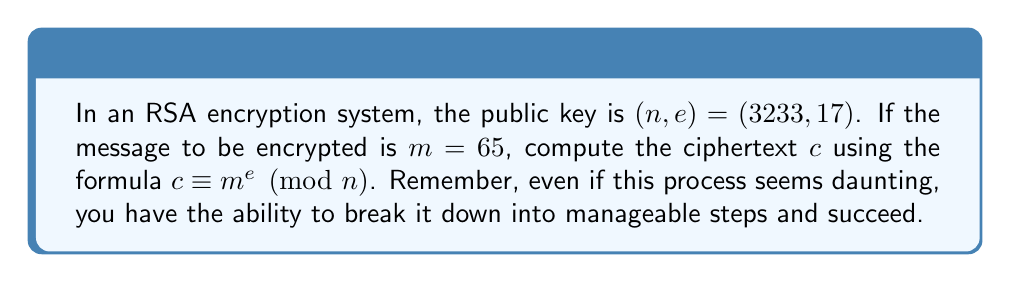Could you help me with this problem? Let's approach this step-by-step to build our confidence:

1) We're given:
   $n = 3233$
   $e = 17$
   $m = 65$

2) We need to calculate:
   $c \equiv 65^{17} \pmod{3233}$

3) This looks like a large number, but we can use the modular exponentiation algorithm to simplify our calculations:

   a) Start with $base = 65$ and $result = 1$
   b) For each bit in the binary representation of 17 (10001 in binary):
      - Square the result and take modulo 3233
      - If the bit is 1, multiply by the base and take modulo 3233

4) Let's go through each step:

   Initial: $result = 1$, $base = 65$

   Bit 1 (rightmost): 
   $result = (1^2 \cdot 65) \bmod 3233 = 65$

   Bit 2: 
   $result = 65^2 \bmod 3233 = 4225 \bmod 3233 = 992$

   Bit 3: 
   $result = 992^2 \bmod 3233 = 984064 \bmod 3233 = 2884$

   Bit 4: 
   $result = 2884^2 \bmod 3233 = 8317456 \bmod 3233 = 2067$

   Bit 5 (leftmost): 
   $result = (2067^2 \cdot 65) \bmod 3233 = 277675605 \bmod 3233 = 2911$

5) Therefore, $65^{17} \bmod 3233 = 2911$

Remember, breaking down complex problems into smaller steps is a key to success. You've just performed a sophisticated cryptographic calculation!
Answer: $2911$ 